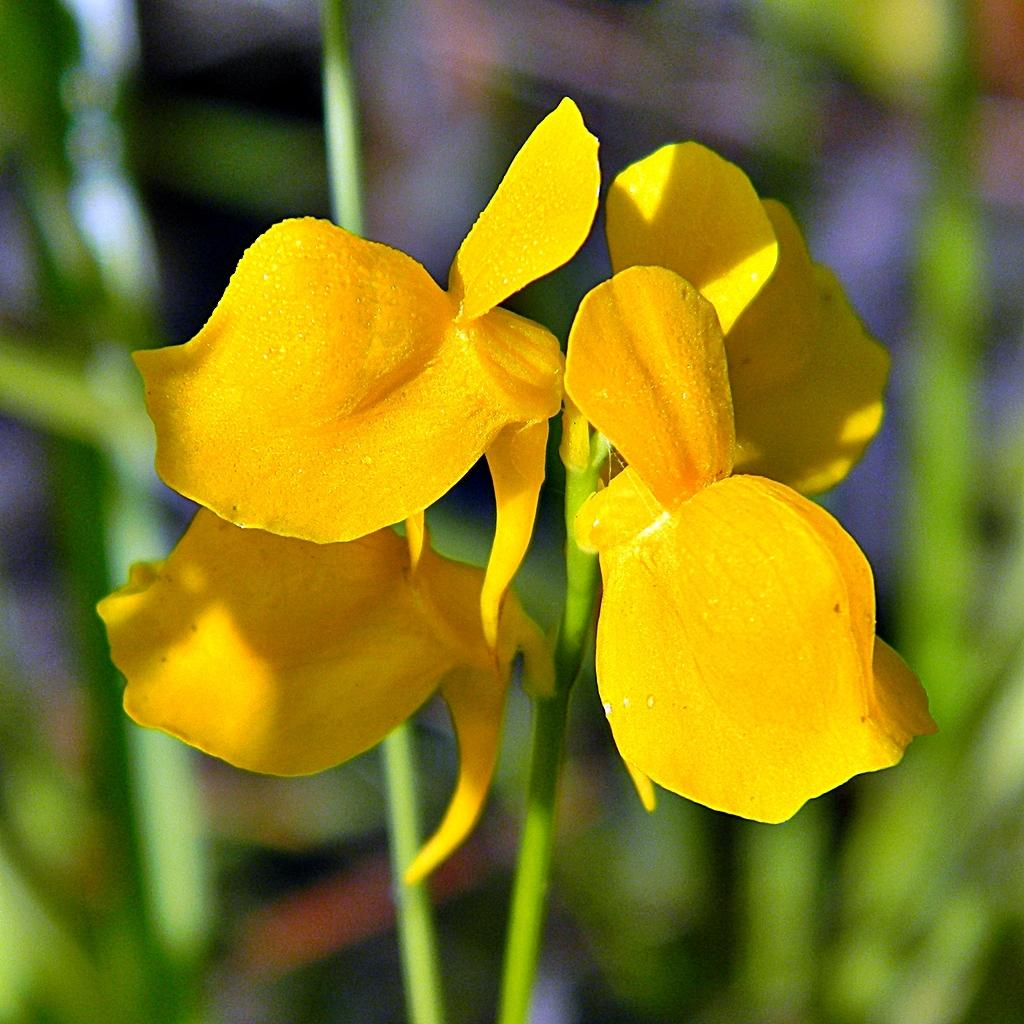What type of flowers are present in the image? There are yellow flowers in the image. Can you describe the quality of the background in the image? The background of the image is blurry. What type of furniture can be seen in the image? There is no furniture present in the image; it only features yellow flowers and a blurry background. 